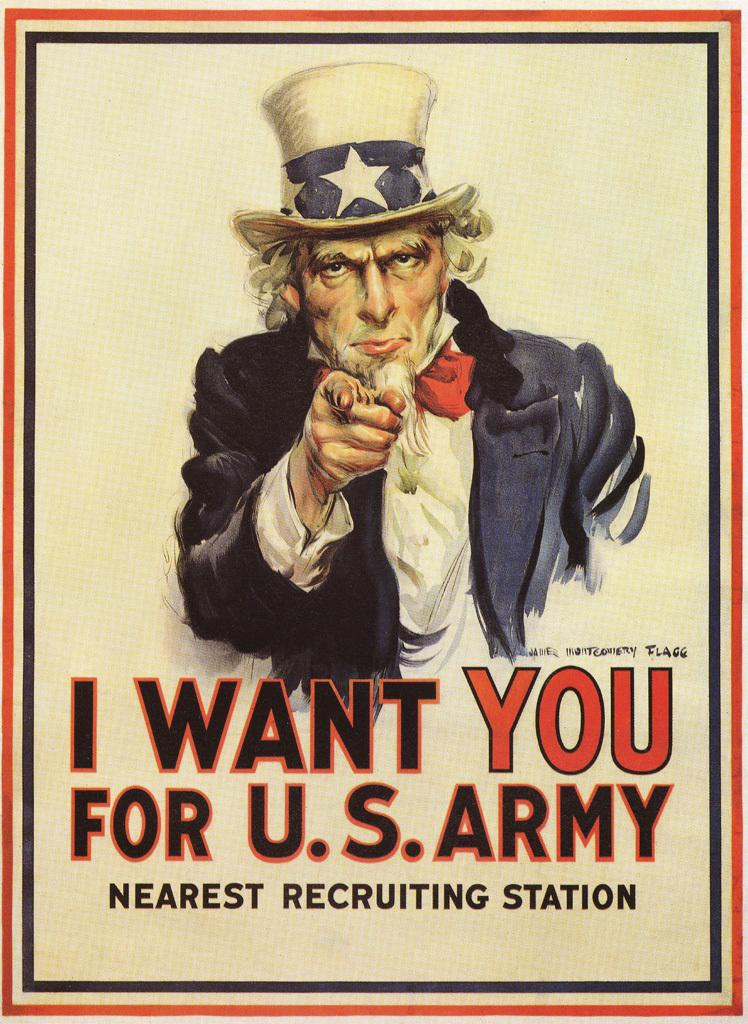<image>
Write a terse but informative summary of the picture. An uncle sam poster that says I want you. 